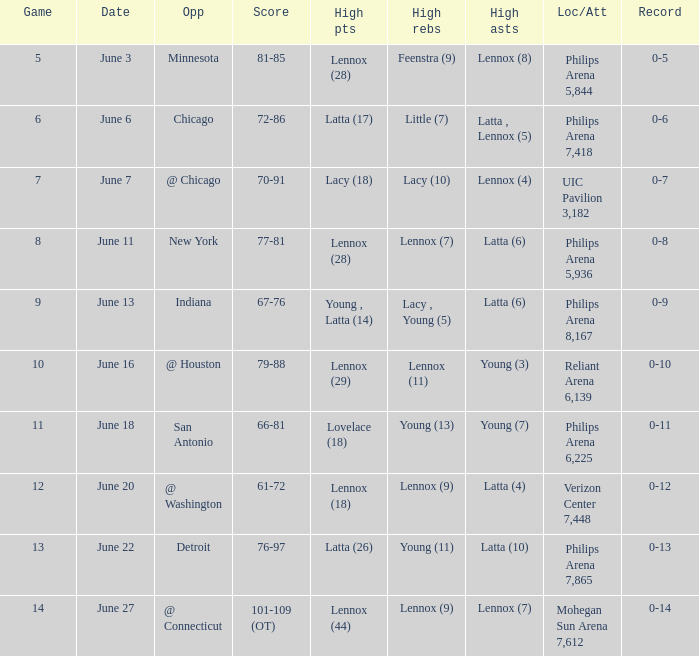What stadium hosted the June 7 game and how many visitors were there? UIC Pavilion 3,182. 